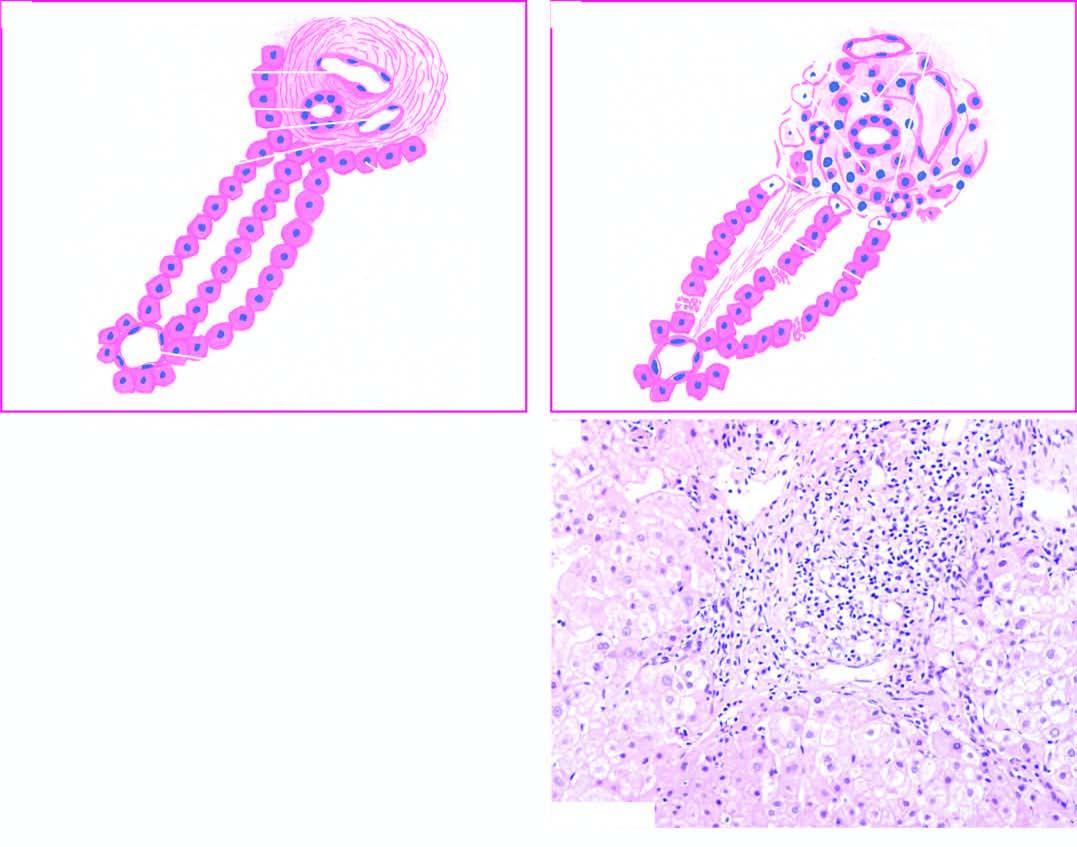s congo red expanded due to increased lymphomononuclear inflammatory cells which are seen to breach the limiting plate ie?
Answer the question using a single word or phrase. No 